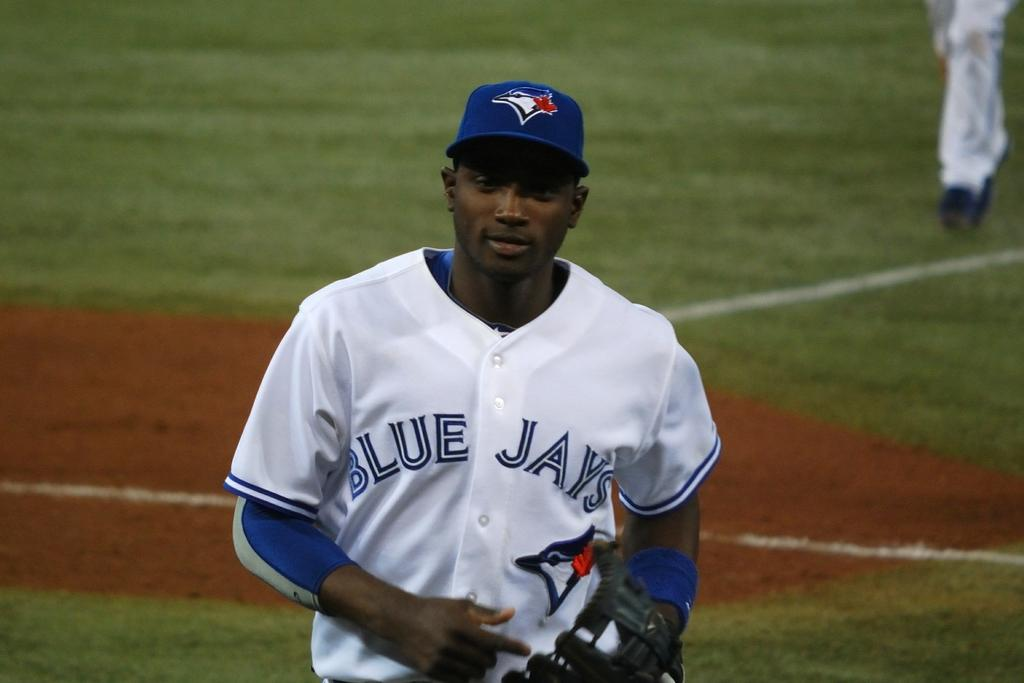<image>
Create a compact narrative representing the image presented. blue jays player in white jersey walking from the field 